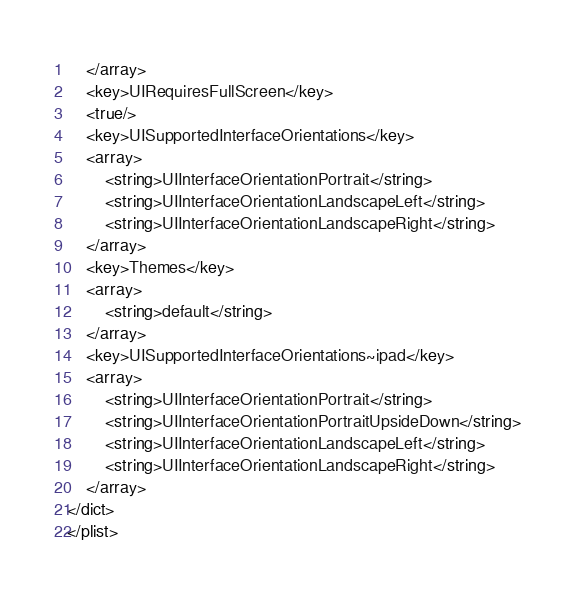Convert code to text. <code><loc_0><loc_0><loc_500><loc_500><_XML_>	</array>
	<key>UIRequiresFullScreen</key>
	<true/>
	<key>UISupportedInterfaceOrientations</key>
	<array>
		<string>UIInterfaceOrientationPortrait</string>
		<string>UIInterfaceOrientationLandscapeLeft</string>
		<string>UIInterfaceOrientationLandscapeRight</string>
	</array>
	<key>Themes</key>
	<array>
		<string>default</string>
	</array>
	<key>UISupportedInterfaceOrientations~ipad</key>
	<array>
		<string>UIInterfaceOrientationPortrait</string>
		<string>UIInterfaceOrientationPortraitUpsideDown</string>
		<string>UIInterfaceOrientationLandscapeLeft</string>
		<string>UIInterfaceOrientationLandscapeRight</string>
	</array>
</dict>
</plist>
</code> 